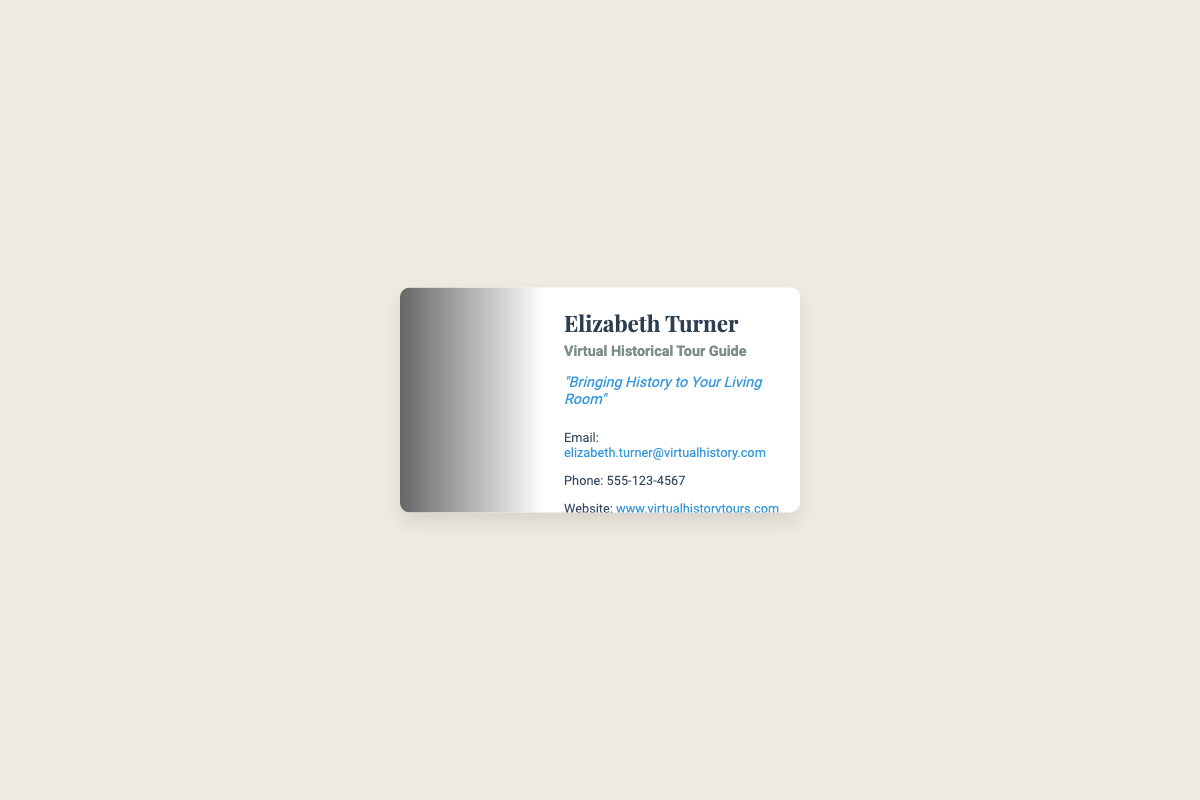What is the name of the tour guide? The name of the tour guide is prominently displayed as "Elizabeth Turner."
Answer: Elizabeth Turner What service does Elizabeth provide? The service offered by Elizabeth is indicated as "Virtual Historical Tour Guide."
Answer: Virtual Historical Tour Guide What is the tagline on the card? The catchy phrase that encapsulates Elizabeth's service is "Bringing History to Your Living Room."
Answer: Bringing History to Your Living Room What is the email address provided? The email address for contact is a direct statement within the contact section of the card.
Answer: elizabeth.turner@virtualhistory.com What is the phone number listed on the card? The phone number can be found in the contact details, which is a specific piece of information on the card.
Answer: 555-123-4567 What colors are used for the tagline? The coloration of the tagline is designed to be visually distinguishable, highlighting it on the card.
Answer: #3498db (blue) What image is used in the card’s design? The card features a background image that represents a famous historical site, enhancing the theme of the service.
Answer: Historical site image What main theme does the business card convey? The card's design and text elements create an inviting atmosphere focused on historical education and virtual experiences.
Answer: Historical education What element is used to enhance the visual appeal of the card? A particular design technique has been employed to add depth and contrast in the visual presentation.
Answer: Gradient overlay 